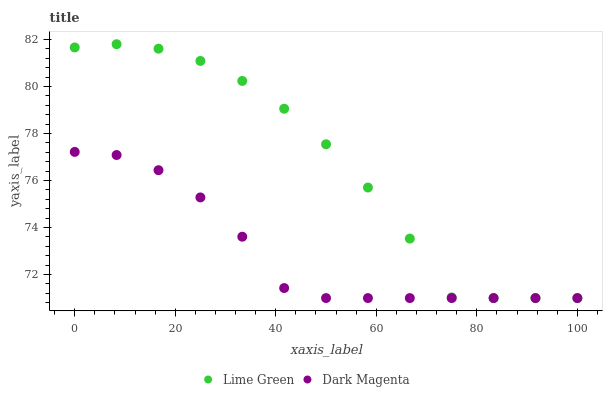Does Dark Magenta have the minimum area under the curve?
Answer yes or no. Yes. Does Lime Green have the maximum area under the curve?
Answer yes or no. Yes. Does Dark Magenta have the maximum area under the curve?
Answer yes or no. No. Is Dark Magenta the smoothest?
Answer yes or no. Yes. Is Lime Green the roughest?
Answer yes or no. Yes. Is Dark Magenta the roughest?
Answer yes or no. No. Does Lime Green have the lowest value?
Answer yes or no. Yes. Does Lime Green have the highest value?
Answer yes or no. Yes. Does Dark Magenta have the highest value?
Answer yes or no. No. Does Dark Magenta intersect Lime Green?
Answer yes or no. Yes. Is Dark Magenta less than Lime Green?
Answer yes or no. No. Is Dark Magenta greater than Lime Green?
Answer yes or no. No. 